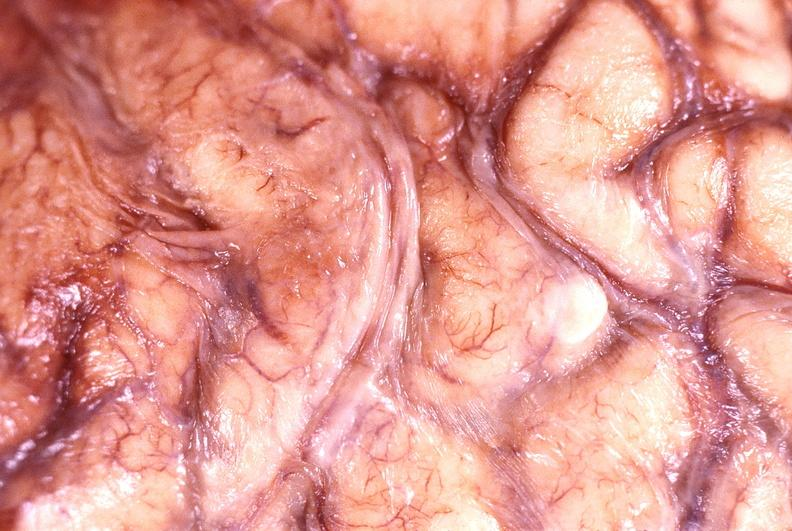s nervous present?
Answer the question using a single word or phrase. Yes 